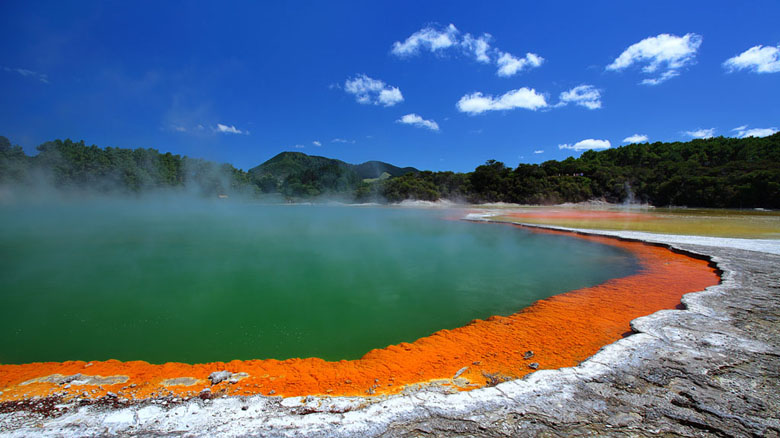What mythical creature could live in such a hot spring? In the depths of this vibrant hot spring, legend speaks of the Serpent of the Searing Depths. This mythical creature, known as Ignis Serpens, is said to inhabit the unseen geothermal caverns beneath Wai-O-Tapu. The serpent thrives in the extreme heat and is believed to be the guardian of the Earth's fiery core. Its scales shimmer in hues of orange and green, mimicking the colors of the hot spring above. The indigenous peoples speak of its formidable power and wisdom, and it is said that the serpent can communicate with those pure of heart, revealing ancient secrets and prophecies about the Earth’s geothermal energies. 